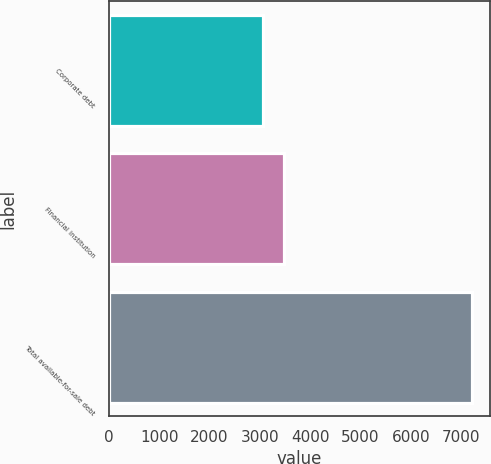Convert chart. <chart><loc_0><loc_0><loc_500><loc_500><bar_chart><fcel>Corporate debt<fcel>Financial institution<fcel>Total available-for-sale debt<nl><fcel>3068<fcel>3482.5<fcel>7213<nl></chart> 